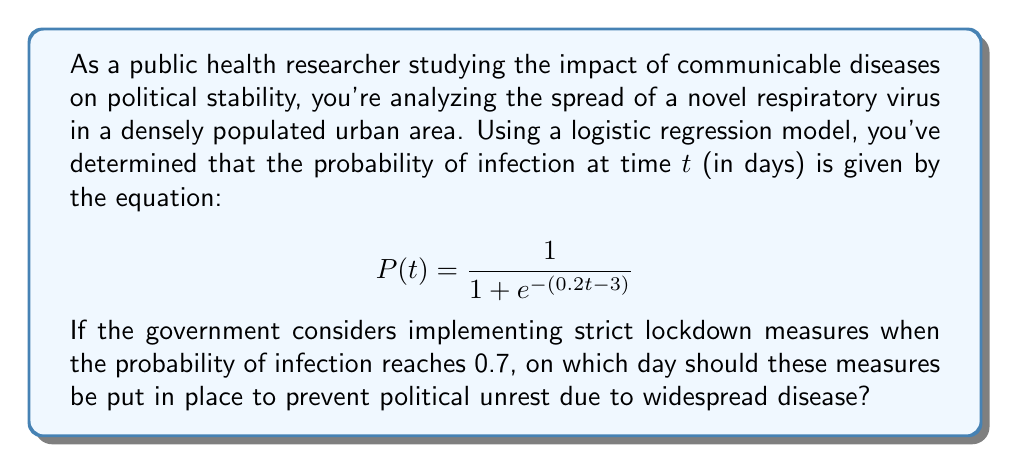Can you answer this question? To solve this problem, we need to find the value of $t$ when $P(t) = 0.7$. Let's approach this step-by-step:

1) We start with the logistic function:
   $$P(t) = \frac{1}{1 + e^{-(0.2t - 3)}}$$

2) We want to find $t$ when $P(t) = 0.7$, so let's set up the equation:
   $$0.7 = \frac{1}{1 + e^{-(0.2t - 3)}}$$

3) To solve this, let's first take the reciprocal of both sides:
   $$\frac{1}{0.7} = 1 + e^{-(0.2t - 3)}$$

4) Simplify the left side:
   $$\frac{10}{7} = 1 + e^{-(0.2t - 3)}$$

5) Subtract 1 from both sides:
   $$\frac{3}{7} = e^{-(0.2t - 3)}$$

6) Take the natural log of both sides:
   $$\ln(\frac{3}{7}) = -(0.2t - 3)$$

7) Multiply both sides by -1:
   $$-\ln(\frac{3}{7}) = 0.2t - 3$$

8) Add 3 to both sides:
   $$3 - \ln(\frac{3}{7}) = 0.2t$$

9) Divide both sides by 0.2:
   $$\frac{3 - \ln(\frac{3}{7})}{0.2} = t$$

10) Calculate the value (rounded to two decimal places):
    $$t \approx 20.55$$

Since we're dealing with days, we need to round up to the nearest whole day. Therefore, the lockdown measures should be implemented on day 21.
Answer: The government should implement strict lockdown measures on day 21 to prevent political unrest due to widespread disease. 